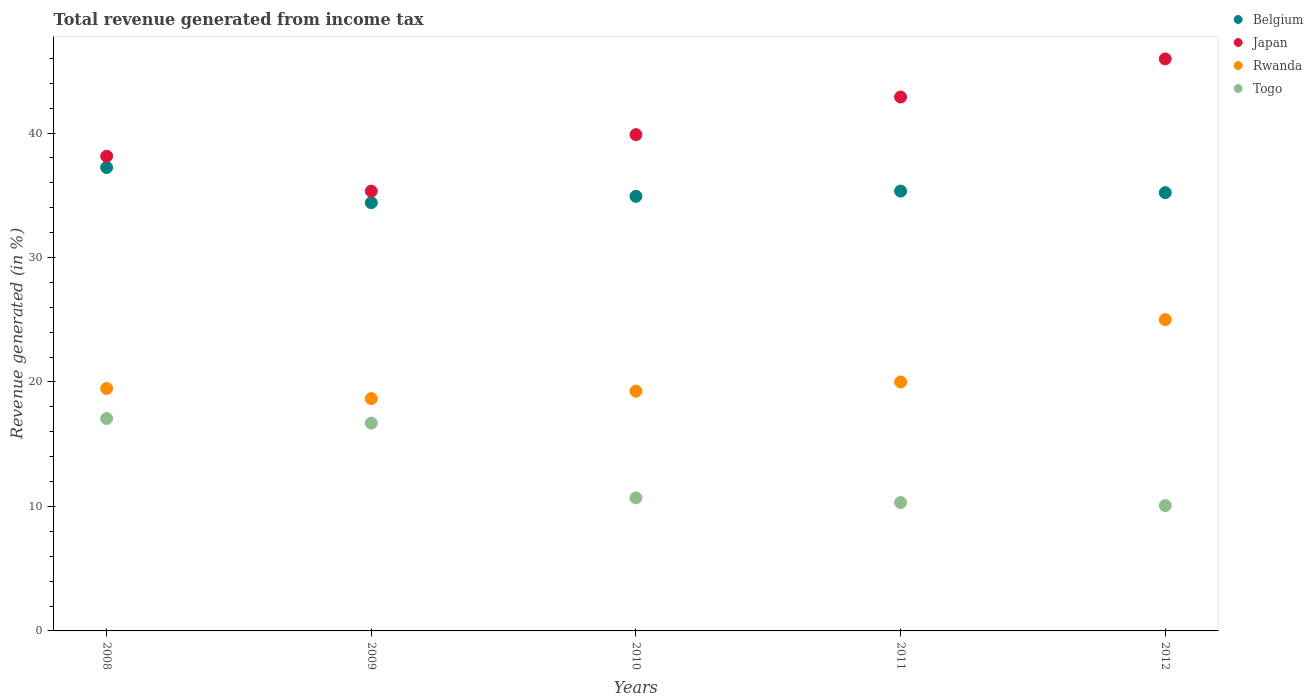What is the total revenue generated in Togo in 2009?
Give a very brief answer. 16.7. Across all years, what is the maximum total revenue generated in Belgium?
Make the answer very short. 37.23. Across all years, what is the minimum total revenue generated in Togo?
Offer a terse response. 10.07. What is the total total revenue generated in Togo in the graph?
Give a very brief answer. 64.84. What is the difference between the total revenue generated in Togo in 2010 and that in 2011?
Provide a succinct answer. 0.38. What is the difference between the total revenue generated in Belgium in 2011 and the total revenue generated in Rwanda in 2008?
Give a very brief answer. 15.86. What is the average total revenue generated in Rwanda per year?
Your answer should be very brief. 20.48. In the year 2008, what is the difference between the total revenue generated in Belgium and total revenue generated in Togo?
Ensure brevity in your answer.  20.17. What is the ratio of the total revenue generated in Japan in 2009 to that in 2012?
Provide a short and direct response. 0.77. What is the difference between the highest and the second highest total revenue generated in Rwanda?
Your response must be concise. 5.01. What is the difference between the highest and the lowest total revenue generated in Belgium?
Provide a short and direct response. 2.83. In how many years, is the total revenue generated in Togo greater than the average total revenue generated in Togo taken over all years?
Make the answer very short. 2. Is the sum of the total revenue generated in Rwanda in 2008 and 2011 greater than the maximum total revenue generated in Belgium across all years?
Your response must be concise. Yes. Is it the case that in every year, the sum of the total revenue generated in Belgium and total revenue generated in Rwanda  is greater than the sum of total revenue generated in Togo and total revenue generated in Japan?
Your answer should be very brief. Yes. Is the total revenue generated in Togo strictly less than the total revenue generated in Japan over the years?
Ensure brevity in your answer.  Yes. Are the values on the major ticks of Y-axis written in scientific E-notation?
Make the answer very short. No. Does the graph contain any zero values?
Ensure brevity in your answer.  No. Where does the legend appear in the graph?
Ensure brevity in your answer.  Top right. What is the title of the graph?
Keep it short and to the point. Total revenue generated from income tax. What is the label or title of the Y-axis?
Keep it short and to the point. Revenue generated (in %). What is the Revenue generated (in %) of Belgium in 2008?
Give a very brief answer. 37.23. What is the Revenue generated (in %) of Japan in 2008?
Your response must be concise. 38.14. What is the Revenue generated (in %) of Rwanda in 2008?
Your answer should be compact. 19.48. What is the Revenue generated (in %) of Togo in 2008?
Your answer should be very brief. 17.06. What is the Revenue generated (in %) in Belgium in 2009?
Offer a very short reply. 34.41. What is the Revenue generated (in %) in Japan in 2009?
Offer a terse response. 35.34. What is the Revenue generated (in %) of Rwanda in 2009?
Keep it short and to the point. 18.66. What is the Revenue generated (in %) in Togo in 2009?
Ensure brevity in your answer.  16.7. What is the Revenue generated (in %) of Belgium in 2010?
Offer a very short reply. 34.92. What is the Revenue generated (in %) of Japan in 2010?
Keep it short and to the point. 39.87. What is the Revenue generated (in %) of Rwanda in 2010?
Your answer should be compact. 19.26. What is the Revenue generated (in %) in Togo in 2010?
Provide a short and direct response. 10.69. What is the Revenue generated (in %) in Belgium in 2011?
Provide a short and direct response. 35.34. What is the Revenue generated (in %) in Japan in 2011?
Offer a terse response. 42.9. What is the Revenue generated (in %) of Rwanda in 2011?
Provide a short and direct response. 20. What is the Revenue generated (in %) in Togo in 2011?
Your answer should be compact. 10.31. What is the Revenue generated (in %) in Belgium in 2012?
Provide a short and direct response. 35.21. What is the Revenue generated (in %) of Japan in 2012?
Offer a terse response. 45.96. What is the Revenue generated (in %) of Rwanda in 2012?
Ensure brevity in your answer.  25.01. What is the Revenue generated (in %) in Togo in 2012?
Offer a terse response. 10.07. Across all years, what is the maximum Revenue generated (in %) in Belgium?
Ensure brevity in your answer.  37.23. Across all years, what is the maximum Revenue generated (in %) in Japan?
Make the answer very short. 45.96. Across all years, what is the maximum Revenue generated (in %) in Rwanda?
Ensure brevity in your answer.  25.01. Across all years, what is the maximum Revenue generated (in %) in Togo?
Offer a terse response. 17.06. Across all years, what is the minimum Revenue generated (in %) in Belgium?
Keep it short and to the point. 34.41. Across all years, what is the minimum Revenue generated (in %) in Japan?
Provide a short and direct response. 35.34. Across all years, what is the minimum Revenue generated (in %) of Rwanda?
Your answer should be compact. 18.66. Across all years, what is the minimum Revenue generated (in %) in Togo?
Keep it short and to the point. 10.07. What is the total Revenue generated (in %) of Belgium in the graph?
Give a very brief answer. 177.11. What is the total Revenue generated (in %) of Japan in the graph?
Keep it short and to the point. 202.2. What is the total Revenue generated (in %) of Rwanda in the graph?
Ensure brevity in your answer.  102.42. What is the total Revenue generated (in %) in Togo in the graph?
Your answer should be compact. 64.84. What is the difference between the Revenue generated (in %) in Belgium in 2008 and that in 2009?
Your answer should be compact. 2.83. What is the difference between the Revenue generated (in %) of Japan in 2008 and that in 2009?
Your response must be concise. 2.8. What is the difference between the Revenue generated (in %) in Rwanda in 2008 and that in 2009?
Provide a succinct answer. 0.81. What is the difference between the Revenue generated (in %) of Togo in 2008 and that in 2009?
Provide a succinct answer. 0.37. What is the difference between the Revenue generated (in %) in Belgium in 2008 and that in 2010?
Your answer should be very brief. 2.32. What is the difference between the Revenue generated (in %) of Japan in 2008 and that in 2010?
Your response must be concise. -1.73. What is the difference between the Revenue generated (in %) of Rwanda in 2008 and that in 2010?
Your answer should be compact. 0.22. What is the difference between the Revenue generated (in %) in Togo in 2008 and that in 2010?
Give a very brief answer. 6.37. What is the difference between the Revenue generated (in %) of Belgium in 2008 and that in 2011?
Offer a terse response. 1.89. What is the difference between the Revenue generated (in %) in Japan in 2008 and that in 2011?
Give a very brief answer. -4.76. What is the difference between the Revenue generated (in %) of Rwanda in 2008 and that in 2011?
Offer a terse response. -0.52. What is the difference between the Revenue generated (in %) of Togo in 2008 and that in 2011?
Your answer should be very brief. 6.75. What is the difference between the Revenue generated (in %) of Belgium in 2008 and that in 2012?
Offer a very short reply. 2.02. What is the difference between the Revenue generated (in %) in Japan in 2008 and that in 2012?
Ensure brevity in your answer.  -7.82. What is the difference between the Revenue generated (in %) in Rwanda in 2008 and that in 2012?
Provide a succinct answer. -5.54. What is the difference between the Revenue generated (in %) in Togo in 2008 and that in 2012?
Provide a short and direct response. 6.99. What is the difference between the Revenue generated (in %) in Belgium in 2009 and that in 2010?
Your answer should be very brief. -0.51. What is the difference between the Revenue generated (in %) in Japan in 2009 and that in 2010?
Your answer should be compact. -4.54. What is the difference between the Revenue generated (in %) of Rwanda in 2009 and that in 2010?
Ensure brevity in your answer.  -0.6. What is the difference between the Revenue generated (in %) of Togo in 2009 and that in 2010?
Offer a terse response. 6. What is the difference between the Revenue generated (in %) in Belgium in 2009 and that in 2011?
Your response must be concise. -0.93. What is the difference between the Revenue generated (in %) in Japan in 2009 and that in 2011?
Your response must be concise. -7.56. What is the difference between the Revenue generated (in %) in Rwanda in 2009 and that in 2011?
Offer a terse response. -1.34. What is the difference between the Revenue generated (in %) of Togo in 2009 and that in 2011?
Provide a succinct answer. 6.38. What is the difference between the Revenue generated (in %) of Belgium in 2009 and that in 2012?
Provide a short and direct response. -0.81. What is the difference between the Revenue generated (in %) in Japan in 2009 and that in 2012?
Keep it short and to the point. -10.62. What is the difference between the Revenue generated (in %) in Rwanda in 2009 and that in 2012?
Offer a very short reply. -6.35. What is the difference between the Revenue generated (in %) in Togo in 2009 and that in 2012?
Ensure brevity in your answer.  6.63. What is the difference between the Revenue generated (in %) in Belgium in 2010 and that in 2011?
Your answer should be very brief. -0.42. What is the difference between the Revenue generated (in %) in Japan in 2010 and that in 2011?
Your answer should be very brief. -3.02. What is the difference between the Revenue generated (in %) of Rwanda in 2010 and that in 2011?
Keep it short and to the point. -0.74. What is the difference between the Revenue generated (in %) of Togo in 2010 and that in 2011?
Offer a very short reply. 0.38. What is the difference between the Revenue generated (in %) of Belgium in 2010 and that in 2012?
Offer a very short reply. -0.3. What is the difference between the Revenue generated (in %) of Japan in 2010 and that in 2012?
Keep it short and to the point. -6.09. What is the difference between the Revenue generated (in %) in Rwanda in 2010 and that in 2012?
Offer a terse response. -5.75. What is the difference between the Revenue generated (in %) of Togo in 2010 and that in 2012?
Your answer should be very brief. 0.62. What is the difference between the Revenue generated (in %) of Belgium in 2011 and that in 2012?
Keep it short and to the point. 0.13. What is the difference between the Revenue generated (in %) of Japan in 2011 and that in 2012?
Offer a very short reply. -3.06. What is the difference between the Revenue generated (in %) in Rwanda in 2011 and that in 2012?
Provide a short and direct response. -5.01. What is the difference between the Revenue generated (in %) in Togo in 2011 and that in 2012?
Ensure brevity in your answer.  0.24. What is the difference between the Revenue generated (in %) of Belgium in 2008 and the Revenue generated (in %) of Japan in 2009?
Provide a short and direct response. 1.9. What is the difference between the Revenue generated (in %) in Belgium in 2008 and the Revenue generated (in %) in Rwanda in 2009?
Your answer should be very brief. 18.57. What is the difference between the Revenue generated (in %) of Belgium in 2008 and the Revenue generated (in %) of Togo in 2009?
Your response must be concise. 20.54. What is the difference between the Revenue generated (in %) in Japan in 2008 and the Revenue generated (in %) in Rwanda in 2009?
Your response must be concise. 19.48. What is the difference between the Revenue generated (in %) of Japan in 2008 and the Revenue generated (in %) of Togo in 2009?
Your answer should be very brief. 21.44. What is the difference between the Revenue generated (in %) in Rwanda in 2008 and the Revenue generated (in %) in Togo in 2009?
Offer a terse response. 2.78. What is the difference between the Revenue generated (in %) in Belgium in 2008 and the Revenue generated (in %) in Japan in 2010?
Provide a short and direct response. -2.64. What is the difference between the Revenue generated (in %) of Belgium in 2008 and the Revenue generated (in %) of Rwanda in 2010?
Provide a succinct answer. 17.97. What is the difference between the Revenue generated (in %) in Belgium in 2008 and the Revenue generated (in %) in Togo in 2010?
Give a very brief answer. 26.54. What is the difference between the Revenue generated (in %) of Japan in 2008 and the Revenue generated (in %) of Rwanda in 2010?
Provide a succinct answer. 18.88. What is the difference between the Revenue generated (in %) in Japan in 2008 and the Revenue generated (in %) in Togo in 2010?
Your response must be concise. 27.45. What is the difference between the Revenue generated (in %) of Rwanda in 2008 and the Revenue generated (in %) of Togo in 2010?
Offer a very short reply. 8.78. What is the difference between the Revenue generated (in %) of Belgium in 2008 and the Revenue generated (in %) of Japan in 2011?
Your answer should be compact. -5.66. What is the difference between the Revenue generated (in %) in Belgium in 2008 and the Revenue generated (in %) in Rwanda in 2011?
Give a very brief answer. 17.23. What is the difference between the Revenue generated (in %) of Belgium in 2008 and the Revenue generated (in %) of Togo in 2011?
Your response must be concise. 26.92. What is the difference between the Revenue generated (in %) in Japan in 2008 and the Revenue generated (in %) in Rwanda in 2011?
Offer a very short reply. 18.14. What is the difference between the Revenue generated (in %) in Japan in 2008 and the Revenue generated (in %) in Togo in 2011?
Offer a terse response. 27.83. What is the difference between the Revenue generated (in %) in Rwanda in 2008 and the Revenue generated (in %) in Togo in 2011?
Provide a succinct answer. 9.16. What is the difference between the Revenue generated (in %) in Belgium in 2008 and the Revenue generated (in %) in Japan in 2012?
Offer a terse response. -8.73. What is the difference between the Revenue generated (in %) of Belgium in 2008 and the Revenue generated (in %) of Rwanda in 2012?
Ensure brevity in your answer.  12.22. What is the difference between the Revenue generated (in %) of Belgium in 2008 and the Revenue generated (in %) of Togo in 2012?
Ensure brevity in your answer.  27.16. What is the difference between the Revenue generated (in %) in Japan in 2008 and the Revenue generated (in %) in Rwanda in 2012?
Provide a short and direct response. 13.13. What is the difference between the Revenue generated (in %) of Japan in 2008 and the Revenue generated (in %) of Togo in 2012?
Provide a succinct answer. 28.07. What is the difference between the Revenue generated (in %) of Rwanda in 2008 and the Revenue generated (in %) of Togo in 2012?
Keep it short and to the point. 9.41. What is the difference between the Revenue generated (in %) of Belgium in 2009 and the Revenue generated (in %) of Japan in 2010?
Give a very brief answer. -5.47. What is the difference between the Revenue generated (in %) in Belgium in 2009 and the Revenue generated (in %) in Rwanda in 2010?
Offer a terse response. 15.14. What is the difference between the Revenue generated (in %) of Belgium in 2009 and the Revenue generated (in %) of Togo in 2010?
Keep it short and to the point. 23.71. What is the difference between the Revenue generated (in %) of Japan in 2009 and the Revenue generated (in %) of Rwanda in 2010?
Your response must be concise. 16.07. What is the difference between the Revenue generated (in %) of Japan in 2009 and the Revenue generated (in %) of Togo in 2010?
Offer a very short reply. 24.64. What is the difference between the Revenue generated (in %) in Rwanda in 2009 and the Revenue generated (in %) in Togo in 2010?
Your response must be concise. 7.97. What is the difference between the Revenue generated (in %) of Belgium in 2009 and the Revenue generated (in %) of Japan in 2011?
Give a very brief answer. -8.49. What is the difference between the Revenue generated (in %) of Belgium in 2009 and the Revenue generated (in %) of Rwanda in 2011?
Your response must be concise. 14.4. What is the difference between the Revenue generated (in %) of Belgium in 2009 and the Revenue generated (in %) of Togo in 2011?
Your answer should be compact. 24.09. What is the difference between the Revenue generated (in %) in Japan in 2009 and the Revenue generated (in %) in Rwanda in 2011?
Make the answer very short. 15.33. What is the difference between the Revenue generated (in %) in Japan in 2009 and the Revenue generated (in %) in Togo in 2011?
Ensure brevity in your answer.  25.02. What is the difference between the Revenue generated (in %) of Rwanda in 2009 and the Revenue generated (in %) of Togo in 2011?
Keep it short and to the point. 8.35. What is the difference between the Revenue generated (in %) in Belgium in 2009 and the Revenue generated (in %) in Japan in 2012?
Offer a terse response. -11.55. What is the difference between the Revenue generated (in %) in Belgium in 2009 and the Revenue generated (in %) in Rwanda in 2012?
Ensure brevity in your answer.  9.39. What is the difference between the Revenue generated (in %) in Belgium in 2009 and the Revenue generated (in %) in Togo in 2012?
Make the answer very short. 24.34. What is the difference between the Revenue generated (in %) of Japan in 2009 and the Revenue generated (in %) of Rwanda in 2012?
Offer a very short reply. 10.32. What is the difference between the Revenue generated (in %) of Japan in 2009 and the Revenue generated (in %) of Togo in 2012?
Provide a short and direct response. 25.27. What is the difference between the Revenue generated (in %) of Rwanda in 2009 and the Revenue generated (in %) of Togo in 2012?
Provide a short and direct response. 8.59. What is the difference between the Revenue generated (in %) of Belgium in 2010 and the Revenue generated (in %) of Japan in 2011?
Make the answer very short. -7.98. What is the difference between the Revenue generated (in %) in Belgium in 2010 and the Revenue generated (in %) in Rwanda in 2011?
Give a very brief answer. 14.91. What is the difference between the Revenue generated (in %) in Belgium in 2010 and the Revenue generated (in %) in Togo in 2011?
Your answer should be compact. 24.6. What is the difference between the Revenue generated (in %) of Japan in 2010 and the Revenue generated (in %) of Rwanda in 2011?
Provide a succinct answer. 19.87. What is the difference between the Revenue generated (in %) of Japan in 2010 and the Revenue generated (in %) of Togo in 2011?
Keep it short and to the point. 29.56. What is the difference between the Revenue generated (in %) in Rwanda in 2010 and the Revenue generated (in %) in Togo in 2011?
Make the answer very short. 8.95. What is the difference between the Revenue generated (in %) of Belgium in 2010 and the Revenue generated (in %) of Japan in 2012?
Offer a terse response. -11.04. What is the difference between the Revenue generated (in %) of Belgium in 2010 and the Revenue generated (in %) of Rwanda in 2012?
Provide a succinct answer. 9.9. What is the difference between the Revenue generated (in %) in Belgium in 2010 and the Revenue generated (in %) in Togo in 2012?
Ensure brevity in your answer.  24.85. What is the difference between the Revenue generated (in %) of Japan in 2010 and the Revenue generated (in %) of Rwanda in 2012?
Provide a short and direct response. 14.86. What is the difference between the Revenue generated (in %) in Japan in 2010 and the Revenue generated (in %) in Togo in 2012?
Make the answer very short. 29.8. What is the difference between the Revenue generated (in %) in Rwanda in 2010 and the Revenue generated (in %) in Togo in 2012?
Provide a succinct answer. 9.19. What is the difference between the Revenue generated (in %) in Belgium in 2011 and the Revenue generated (in %) in Japan in 2012?
Make the answer very short. -10.62. What is the difference between the Revenue generated (in %) of Belgium in 2011 and the Revenue generated (in %) of Rwanda in 2012?
Your response must be concise. 10.33. What is the difference between the Revenue generated (in %) of Belgium in 2011 and the Revenue generated (in %) of Togo in 2012?
Make the answer very short. 25.27. What is the difference between the Revenue generated (in %) of Japan in 2011 and the Revenue generated (in %) of Rwanda in 2012?
Ensure brevity in your answer.  17.88. What is the difference between the Revenue generated (in %) in Japan in 2011 and the Revenue generated (in %) in Togo in 2012?
Offer a very short reply. 32.83. What is the difference between the Revenue generated (in %) in Rwanda in 2011 and the Revenue generated (in %) in Togo in 2012?
Your answer should be very brief. 9.93. What is the average Revenue generated (in %) in Belgium per year?
Give a very brief answer. 35.42. What is the average Revenue generated (in %) in Japan per year?
Give a very brief answer. 40.44. What is the average Revenue generated (in %) of Rwanda per year?
Keep it short and to the point. 20.48. What is the average Revenue generated (in %) of Togo per year?
Ensure brevity in your answer.  12.97. In the year 2008, what is the difference between the Revenue generated (in %) in Belgium and Revenue generated (in %) in Japan?
Make the answer very short. -0.91. In the year 2008, what is the difference between the Revenue generated (in %) in Belgium and Revenue generated (in %) in Rwanda?
Your answer should be very brief. 17.76. In the year 2008, what is the difference between the Revenue generated (in %) in Belgium and Revenue generated (in %) in Togo?
Provide a short and direct response. 20.17. In the year 2008, what is the difference between the Revenue generated (in %) of Japan and Revenue generated (in %) of Rwanda?
Offer a terse response. 18.66. In the year 2008, what is the difference between the Revenue generated (in %) in Japan and Revenue generated (in %) in Togo?
Your answer should be compact. 21.08. In the year 2008, what is the difference between the Revenue generated (in %) of Rwanda and Revenue generated (in %) of Togo?
Offer a very short reply. 2.41. In the year 2009, what is the difference between the Revenue generated (in %) in Belgium and Revenue generated (in %) in Japan?
Provide a succinct answer. -0.93. In the year 2009, what is the difference between the Revenue generated (in %) of Belgium and Revenue generated (in %) of Rwanda?
Provide a succinct answer. 15.74. In the year 2009, what is the difference between the Revenue generated (in %) of Belgium and Revenue generated (in %) of Togo?
Provide a short and direct response. 17.71. In the year 2009, what is the difference between the Revenue generated (in %) in Japan and Revenue generated (in %) in Rwanda?
Offer a very short reply. 16.67. In the year 2009, what is the difference between the Revenue generated (in %) in Japan and Revenue generated (in %) in Togo?
Your answer should be very brief. 18.64. In the year 2009, what is the difference between the Revenue generated (in %) of Rwanda and Revenue generated (in %) of Togo?
Make the answer very short. 1.97. In the year 2010, what is the difference between the Revenue generated (in %) of Belgium and Revenue generated (in %) of Japan?
Your answer should be very brief. -4.96. In the year 2010, what is the difference between the Revenue generated (in %) in Belgium and Revenue generated (in %) in Rwanda?
Keep it short and to the point. 15.65. In the year 2010, what is the difference between the Revenue generated (in %) of Belgium and Revenue generated (in %) of Togo?
Your answer should be very brief. 24.22. In the year 2010, what is the difference between the Revenue generated (in %) in Japan and Revenue generated (in %) in Rwanda?
Give a very brief answer. 20.61. In the year 2010, what is the difference between the Revenue generated (in %) of Japan and Revenue generated (in %) of Togo?
Keep it short and to the point. 29.18. In the year 2010, what is the difference between the Revenue generated (in %) of Rwanda and Revenue generated (in %) of Togo?
Ensure brevity in your answer.  8.57. In the year 2011, what is the difference between the Revenue generated (in %) of Belgium and Revenue generated (in %) of Japan?
Make the answer very short. -7.56. In the year 2011, what is the difference between the Revenue generated (in %) in Belgium and Revenue generated (in %) in Rwanda?
Keep it short and to the point. 15.34. In the year 2011, what is the difference between the Revenue generated (in %) in Belgium and Revenue generated (in %) in Togo?
Offer a terse response. 25.03. In the year 2011, what is the difference between the Revenue generated (in %) of Japan and Revenue generated (in %) of Rwanda?
Offer a terse response. 22.89. In the year 2011, what is the difference between the Revenue generated (in %) of Japan and Revenue generated (in %) of Togo?
Your answer should be compact. 32.58. In the year 2011, what is the difference between the Revenue generated (in %) in Rwanda and Revenue generated (in %) in Togo?
Provide a short and direct response. 9.69. In the year 2012, what is the difference between the Revenue generated (in %) in Belgium and Revenue generated (in %) in Japan?
Offer a terse response. -10.74. In the year 2012, what is the difference between the Revenue generated (in %) in Belgium and Revenue generated (in %) in Rwanda?
Offer a very short reply. 10.2. In the year 2012, what is the difference between the Revenue generated (in %) of Belgium and Revenue generated (in %) of Togo?
Keep it short and to the point. 25.14. In the year 2012, what is the difference between the Revenue generated (in %) of Japan and Revenue generated (in %) of Rwanda?
Provide a succinct answer. 20.95. In the year 2012, what is the difference between the Revenue generated (in %) in Japan and Revenue generated (in %) in Togo?
Keep it short and to the point. 35.89. In the year 2012, what is the difference between the Revenue generated (in %) in Rwanda and Revenue generated (in %) in Togo?
Give a very brief answer. 14.94. What is the ratio of the Revenue generated (in %) in Belgium in 2008 to that in 2009?
Keep it short and to the point. 1.08. What is the ratio of the Revenue generated (in %) in Japan in 2008 to that in 2009?
Ensure brevity in your answer.  1.08. What is the ratio of the Revenue generated (in %) in Rwanda in 2008 to that in 2009?
Offer a terse response. 1.04. What is the ratio of the Revenue generated (in %) of Togo in 2008 to that in 2009?
Provide a succinct answer. 1.02. What is the ratio of the Revenue generated (in %) in Belgium in 2008 to that in 2010?
Provide a succinct answer. 1.07. What is the ratio of the Revenue generated (in %) in Japan in 2008 to that in 2010?
Provide a short and direct response. 0.96. What is the ratio of the Revenue generated (in %) in Rwanda in 2008 to that in 2010?
Give a very brief answer. 1.01. What is the ratio of the Revenue generated (in %) in Togo in 2008 to that in 2010?
Offer a very short reply. 1.6. What is the ratio of the Revenue generated (in %) of Belgium in 2008 to that in 2011?
Offer a terse response. 1.05. What is the ratio of the Revenue generated (in %) of Japan in 2008 to that in 2011?
Ensure brevity in your answer.  0.89. What is the ratio of the Revenue generated (in %) of Rwanda in 2008 to that in 2011?
Your response must be concise. 0.97. What is the ratio of the Revenue generated (in %) in Togo in 2008 to that in 2011?
Ensure brevity in your answer.  1.65. What is the ratio of the Revenue generated (in %) of Belgium in 2008 to that in 2012?
Your answer should be very brief. 1.06. What is the ratio of the Revenue generated (in %) in Japan in 2008 to that in 2012?
Ensure brevity in your answer.  0.83. What is the ratio of the Revenue generated (in %) in Rwanda in 2008 to that in 2012?
Offer a terse response. 0.78. What is the ratio of the Revenue generated (in %) of Togo in 2008 to that in 2012?
Provide a short and direct response. 1.69. What is the ratio of the Revenue generated (in %) in Belgium in 2009 to that in 2010?
Provide a succinct answer. 0.99. What is the ratio of the Revenue generated (in %) in Japan in 2009 to that in 2010?
Your answer should be very brief. 0.89. What is the ratio of the Revenue generated (in %) in Rwanda in 2009 to that in 2010?
Your answer should be compact. 0.97. What is the ratio of the Revenue generated (in %) of Togo in 2009 to that in 2010?
Make the answer very short. 1.56. What is the ratio of the Revenue generated (in %) of Belgium in 2009 to that in 2011?
Ensure brevity in your answer.  0.97. What is the ratio of the Revenue generated (in %) in Japan in 2009 to that in 2011?
Make the answer very short. 0.82. What is the ratio of the Revenue generated (in %) in Rwanda in 2009 to that in 2011?
Provide a succinct answer. 0.93. What is the ratio of the Revenue generated (in %) of Togo in 2009 to that in 2011?
Give a very brief answer. 1.62. What is the ratio of the Revenue generated (in %) in Belgium in 2009 to that in 2012?
Offer a very short reply. 0.98. What is the ratio of the Revenue generated (in %) in Japan in 2009 to that in 2012?
Your answer should be very brief. 0.77. What is the ratio of the Revenue generated (in %) in Rwanda in 2009 to that in 2012?
Your answer should be compact. 0.75. What is the ratio of the Revenue generated (in %) in Togo in 2009 to that in 2012?
Keep it short and to the point. 1.66. What is the ratio of the Revenue generated (in %) in Belgium in 2010 to that in 2011?
Give a very brief answer. 0.99. What is the ratio of the Revenue generated (in %) of Japan in 2010 to that in 2011?
Ensure brevity in your answer.  0.93. What is the ratio of the Revenue generated (in %) of Togo in 2010 to that in 2011?
Offer a very short reply. 1.04. What is the ratio of the Revenue generated (in %) of Belgium in 2010 to that in 2012?
Provide a succinct answer. 0.99. What is the ratio of the Revenue generated (in %) in Japan in 2010 to that in 2012?
Ensure brevity in your answer.  0.87. What is the ratio of the Revenue generated (in %) in Rwanda in 2010 to that in 2012?
Your answer should be compact. 0.77. What is the ratio of the Revenue generated (in %) of Togo in 2010 to that in 2012?
Provide a succinct answer. 1.06. What is the ratio of the Revenue generated (in %) in Belgium in 2011 to that in 2012?
Ensure brevity in your answer.  1. What is the ratio of the Revenue generated (in %) of Japan in 2011 to that in 2012?
Offer a very short reply. 0.93. What is the ratio of the Revenue generated (in %) in Rwanda in 2011 to that in 2012?
Your answer should be very brief. 0.8. What is the ratio of the Revenue generated (in %) in Togo in 2011 to that in 2012?
Offer a terse response. 1.02. What is the difference between the highest and the second highest Revenue generated (in %) of Belgium?
Your answer should be very brief. 1.89. What is the difference between the highest and the second highest Revenue generated (in %) in Japan?
Provide a succinct answer. 3.06. What is the difference between the highest and the second highest Revenue generated (in %) in Rwanda?
Provide a short and direct response. 5.01. What is the difference between the highest and the second highest Revenue generated (in %) of Togo?
Your answer should be very brief. 0.37. What is the difference between the highest and the lowest Revenue generated (in %) of Belgium?
Offer a very short reply. 2.83. What is the difference between the highest and the lowest Revenue generated (in %) in Japan?
Your answer should be very brief. 10.62. What is the difference between the highest and the lowest Revenue generated (in %) of Rwanda?
Offer a very short reply. 6.35. What is the difference between the highest and the lowest Revenue generated (in %) of Togo?
Provide a succinct answer. 6.99. 